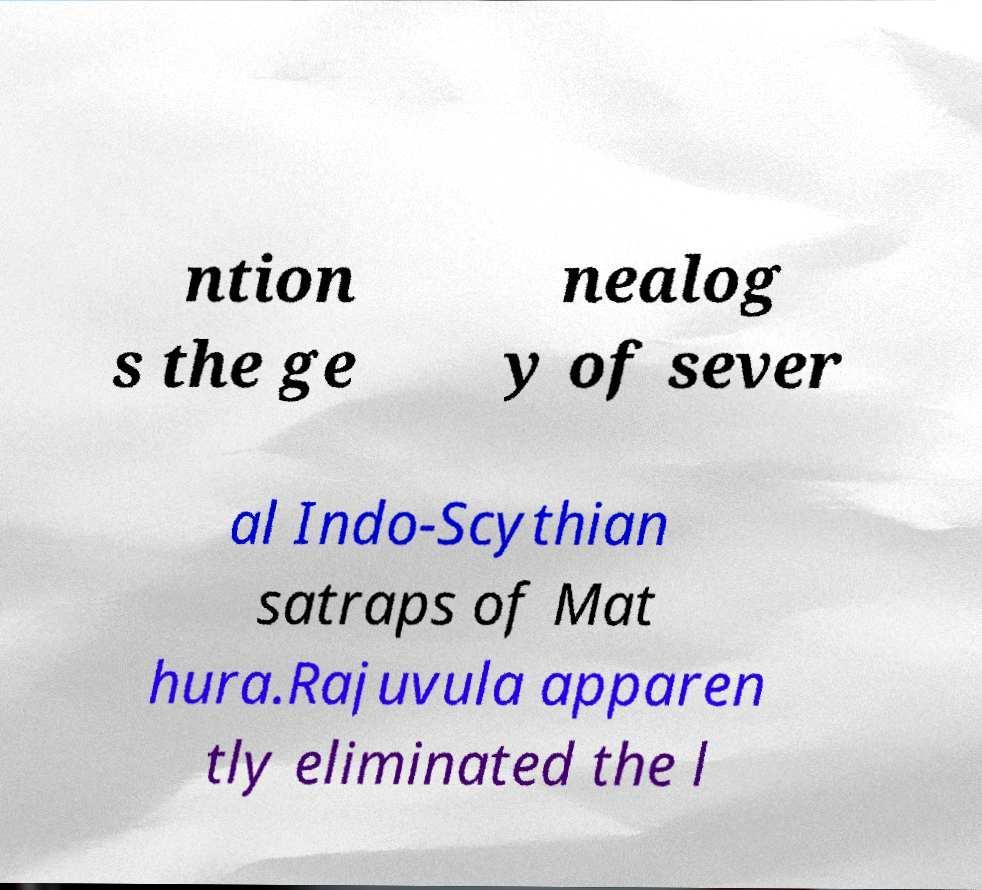Please read and relay the text visible in this image. What does it say? ntion s the ge nealog y of sever al Indo-Scythian satraps of Mat hura.Rajuvula apparen tly eliminated the l 